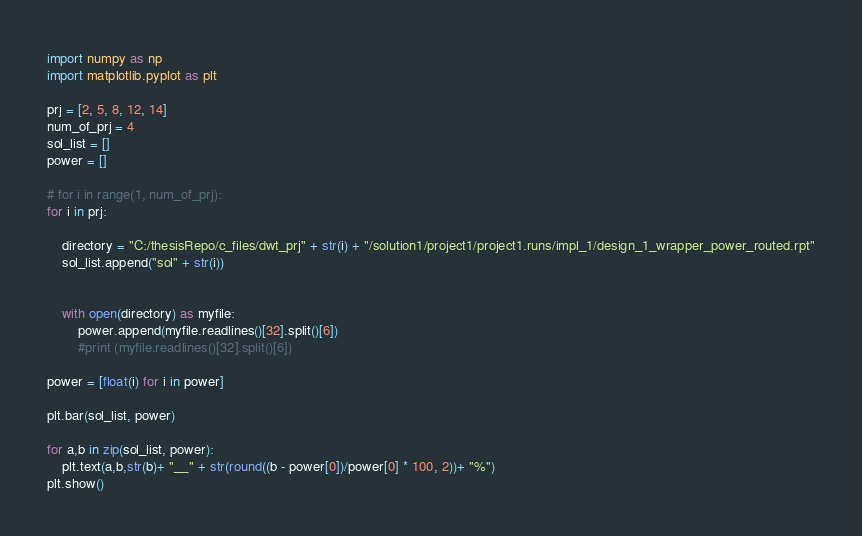<code> <loc_0><loc_0><loc_500><loc_500><_Python_>import numpy as np
import matplotlib.pyplot as plt

prj = [2, 5, 8, 12, 14]
num_of_prj = 4
sol_list = []
power = []

# for i in range(1, num_of_prj):
for i in prj:

    directory = "C:/thesisRepo/c_files/dwt_prj" + str(i) + "/solution1/project1/project1.runs/impl_1/design_1_wrapper_power_routed.rpt"
    sol_list.append("sol" + str(i))
    
    
    with open(directory) as myfile:
        power.append(myfile.readlines()[32].split()[6])
        #print (myfile.readlines()[32].split()[6])

power = [float(i) for i in power]        

plt.bar(sol_list, power)

for a,b in zip(sol_list, power):
    plt.text(a,b,str(b)+ "__" + str(round((b - power[0])/power[0] * 100, 2))+ "%")
plt.show()</code> 